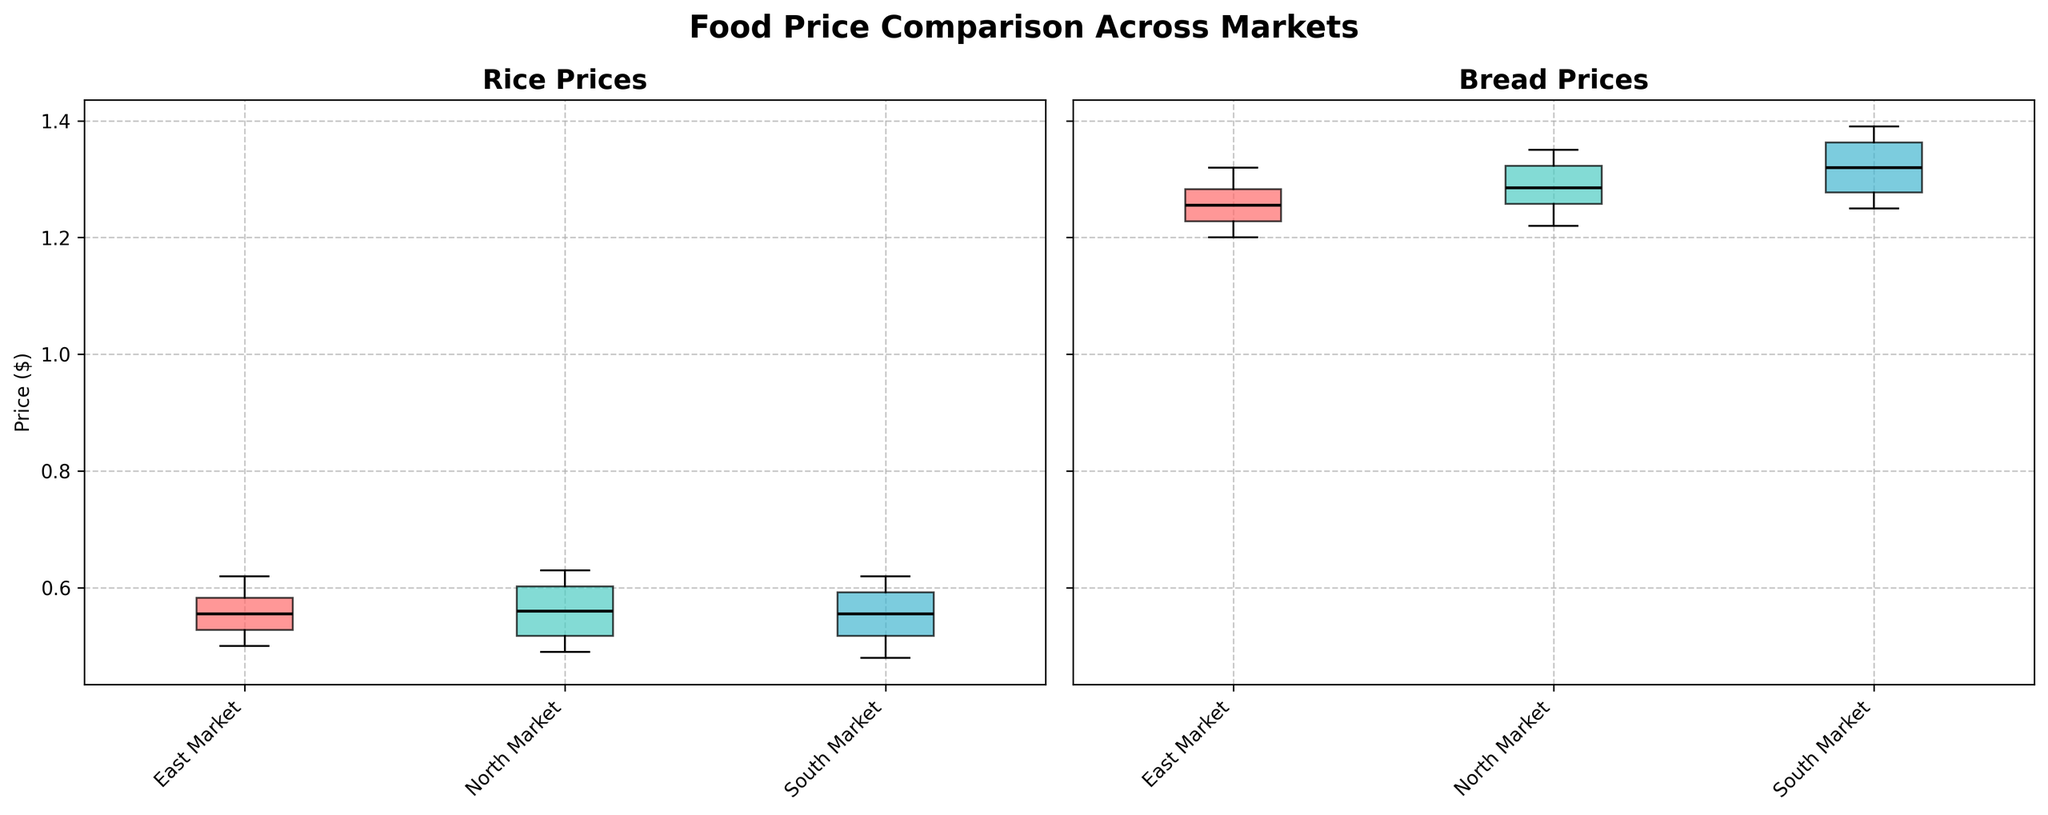What are the markets compared in the figure? The figure compares East Market, North Market, and South Market. This can be seen from the x-axis tick labels under each subplot.
Answer: East Market, North Market, and South Market Which market has the highest median price for rice? To determine this, look at the median line (black line) in the box plots for rice in each market. The market with the highest median line will have the highest median price.
Answer: North Market What is the trend of bread prices in East Market over the past year? This question involves observing the overall distribution of bread prices in the box plot for East Market. The median and quartiles of the box plot can indicate whether bread prices have been increasing or decreasing.
Answer: Increasing Compare the variability of bread prices between North Market and South Market. The variability can be assessed by looking at the interquartile range (IQR) of the box plots. A larger IQR indicates higher variability.
Answer: South Market has higher variability Which market shows the most stable rice prices over the past year? Stability can be evaluated by observing the narrowness of the interquartile range (IQR) and the shorter whiskers in the box plot. The market with the narrowest IQR and the shortest whiskers is the most stable.
Answer: East Market What is the general pattern of food prices in the figure? This involves summarizing the general visual patterns observed in the box plots. For example, whether prices are generally increasing in all markets or if one market stands out.
Answer: Prices generally increase over time Are there any outliers in the bread prices in North Market? Outliers in box plots are represented by dots or asterisks outside the whiskers. We need to look at the North Market box plot for bread to check if there are any such symbols.
Answer: No Between rice and bread, which product shows higher median prices across all markets? Compare the median lines in the box plots for rice and bread in each market. The product with consistently higher median lines across all markets has higher median prices.
Answer: Bread In which market do bread prices have the widest range? The range can be assessed by the length of the whiskers. The market with the longest whiskers has the widest range.
Answer: South Market What is the similarity in rice prices between East Market and South Market? Similarity can be judged based on how close the medians, quartiles, and ranges of the box plots are between East Market and South Market for rice. If they are close, then prices are similar.
Answer: Prices are quite similar 